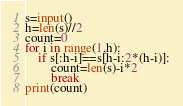<code> <loc_0><loc_0><loc_500><loc_500><_Python_>s=input()
h=len(s)//2
count=0
for i in range(1,h):
    if s[:h-i]==s[h-i:2*(h-i)]:
        count=len(s)-i*2
        break
print(count)</code> 